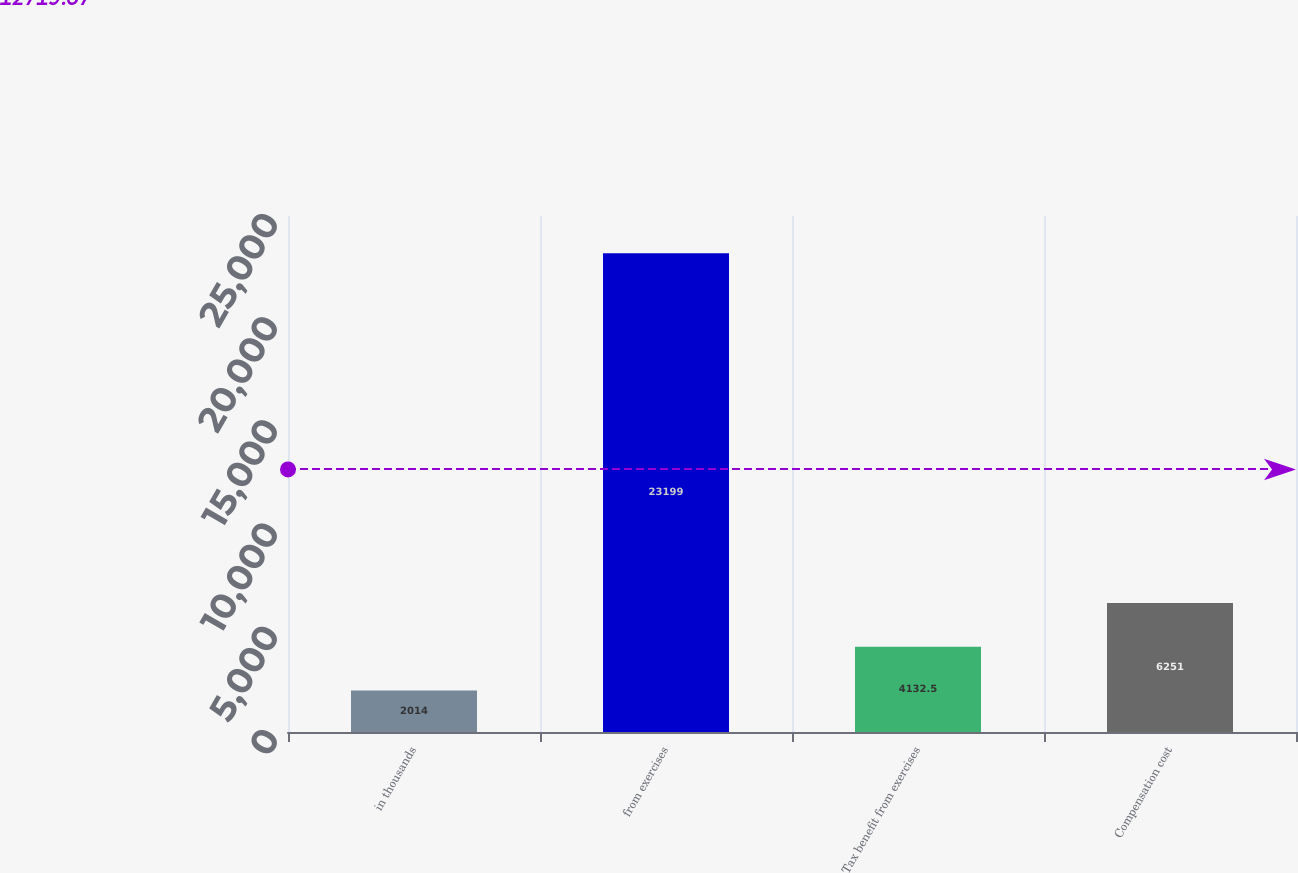<chart> <loc_0><loc_0><loc_500><loc_500><bar_chart><fcel>in thousands<fcel>from exercises<fcel>Tax benefit from exercises<fcel>Compensation cost<nl><fcel>2014<fcel>23199<fcel>4132.5<fcel>6251<nl></chart> 